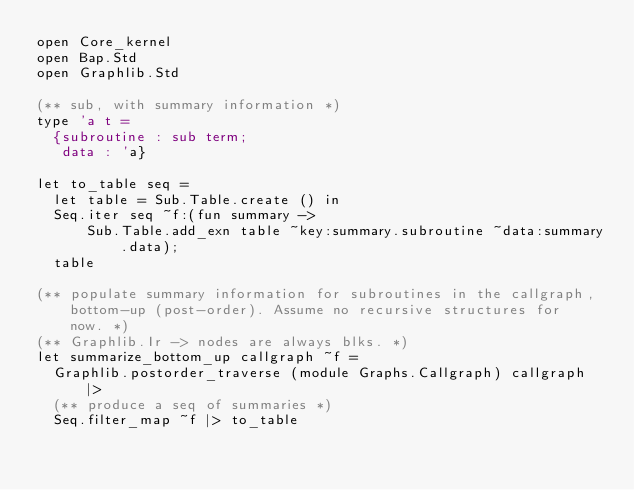Convert code to text. <code><loc_0><loc_0><loc_500><loc_500><_OCaml_>open Core_kernel
open Bap.Std
open Graphlib.Std

(** sub, with summary information *)
type 'a t =
  {subroutine : sub term;
   data : 'a}

let to_table seq =
  let table = Sub.Table.create () in
  Seq.iter seq ~f:(fun summary ->
      Sub.Table.add_exn table ~key:summary.subroutine ~data:summary.data);
  table

(** populate summary information for subroutines in the callgraph,
    bottom-up (post-order). Assume no recursive structures for
    now. *)
(** Graphlib.Ir -> nodes are always blks. *)
let summarize_bottom_up callgraph ~f =
  Graphlib.postorder_traverse (module Graphs.Callgraph) callgraph |>
  (** produce a seq of summaries *)
  Seq.filter_map ~f |> to_table
</code> 